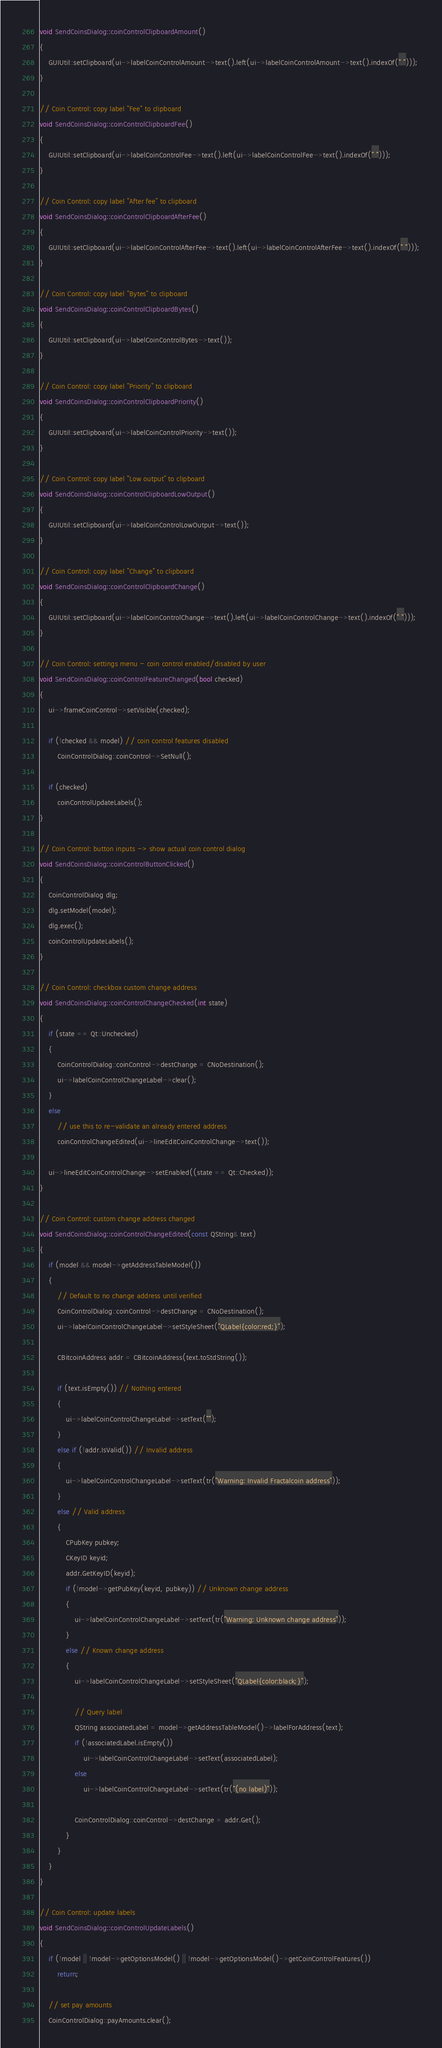Convert code to text. <code><loc_0><loc_0><loc_500><loc_500><_C++_>void SendCoinsDialog::coinControlClipboardAmount()
{
    GUIUtil::setClipboard(ui->labelCoinControlAmount->text().left(ui->labelCoinControlAmount->text().indexOf(" ")));
}

// Coin Control: copy label "Fee" to clipboard
void SendCoinsDialog::coinControlClipboardFee()
{
    GUIUtil::setClipboard(ui->labelCoinControlFee->text().left(ui->labelCoinControlFee->text().indexOf(" ")));
}

// Coin Control: copy label "After fee" to clipboard
void SendCoinsDialog::coinControlClipboardAfterFee()
{
    GUIUtil::setClipboard(ui->labelCoinControlAfterFee->text().left(ui->labelCoinControlAfterFee->text().indexOf(" ")));
}

// Coin Control: copy label "Bytes" to clipboard
void SendCoinsDialog::coinControlClipboardBytes()
{
    GUIUtil::setClipboard(ui->labelCoinControlBytes->text());
}

// Coin Control: copy label "Priority" to clipboard
void SendCoinsDialog::coinControlClipboardPriority()
{
    GUIUtil::setClipboard(ui->labelCoinControlPriority->text());
}

// Coin Control: copy label "Low output" to clipboard
void SendCoinsDialog::coinControlClipboardLowOutput()
{
    GUIUtil::setClipboard(ui->labelCoinControlLowOutput->text());
}

// Coin Control: copy label "Change" to clipboard
void SendCoinsDialog::coinControlClipboardChange()
{
    GUIUtil::setClipboard(ui->labelCoinControlChange->text().left(ui->labelCoinControlChange->text().indexOf(" ")));
}

// Coin Control: settings menu - coin control enabled/disabled by user
void SendCoinsDialog::coinControlFeatureChanged(bool checked)
{
    ui->frameCoinControl->setVisible(checked);

    if (!checked && model) // coin control features disabled
        CoinControlDialog::coinControl->SetNull();

    if (checked)
        coinControlUpdateLabels();
}

// Coin Control: button inputs -> show actual coin control dialog
void SendCoinsDialog::coinControlButtonClicked()
{
    CoinControlDialog dlg;
    dlg.setModel(model);
    dlg.exec();
    coinControlUpdateLabels();
}

// Coin Control: checkbox custom change address
void SendCoinsDialog::coinControlChangeChecked(int state)
{
    if (state == Qt::Unchecked)
    {
        CoinControlDialog::coinControl->destChange = CNoDestination();
        ui->labelCoinControlChangeLabel->clear();
    }
    else
        // use this to re-validate an already entered address
        coinControlChangeEdited(ui->lineEditCoinControlChange->text());

    ui->lineEditCoinControlChange->setEnabled((state == Qt::Checked));
}

// Coin Control: custom change address changed
void SendCoinsDialog::coinControlChangeEdited(const QString& text)
{
    if (model && model->getAddressTableModel())
    {
        // Default to no change address until verified
        CoinControlDialog::coinControl->destChange = CNoDestination();
        ui->labelCoinControlChangeLabel->setStyleSheet("QLabel{color:red;}");

        CBitcoinAddress addr = CBitcoinAddress(text.toStdString());

        if (text.isEmpty()) // Nothing entered
        {
            ui->labelCoinControlChangeLabel->setText("");
        }
        else if (!addr.IsValid()) // Invalid address
        {
            ui->labelCoinControlChangeLabel->setText(tr("Warning: Invalid Fractalcoin address"));
        }
        else // Valid address
        {
            CPubKey pubkey;
            CKeyID keyid;
            addr.GetKeyID(keyid);
            if (!model->getPubKey(keyid, pubkey)) // Unknown change address
            {
                ui->labelCoinControlChangeLabel->setText(tr("Warning: Unknown change address"));
            }
            else // Known change address
            {
                ui->labelCoinControlChangeLabel->setStyleSheet("QLabel{color:black;}");

                // Query label
                QString associatedLabel = model->getAddressTableModel()->labelForAddress(text);
                if (!associatedLabel.isEmpty())
                    ui->labelCoinControlChangeLabel->setText(associatedLabel);
                else
                    ui->labelCoinControlChangeLabel->setText(tr("(no label)"));

                CoinControlDialog::coinControl->destChange = addr.Get();
            }
        }
    }
}

// Coin Control: update labels
void SendCoinsDialog::coinControlUpdateLabels()
{
    if (!model || !model->getOptionsModel() || !model->getOptionsModel()->getCoinControlFeatures())
        return;

    // set pay amounts
    CoinControlDialog::payAmounts.clear();</code> 